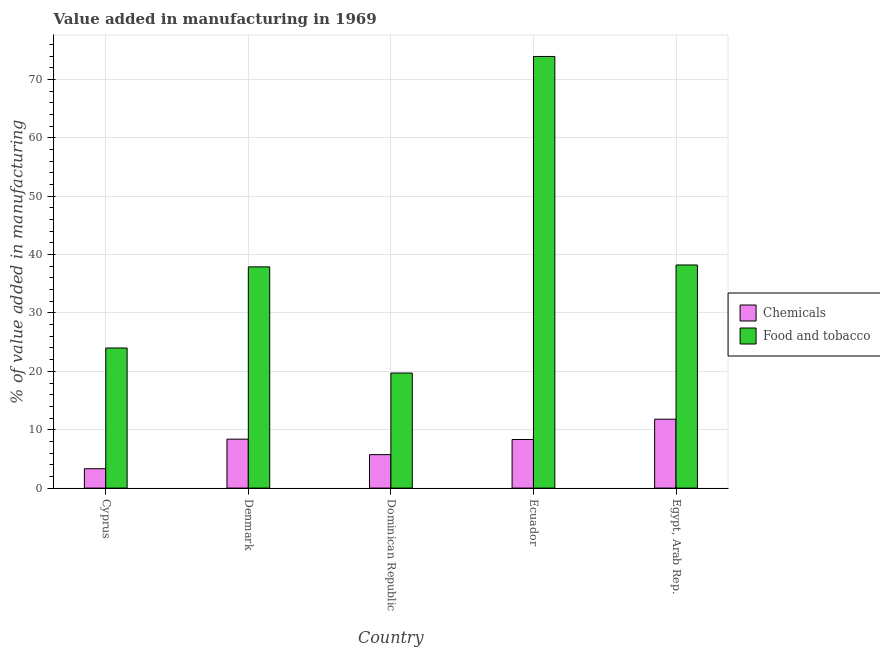How many different coloured bars are there?
Make the answer very short. 2. Are the number of bars on each tick of the X-axis equal?
Offer a terse response. Yes. How many bars are there on the 3rd tick from the left?
Give a very brief answer. 2. How many bars are there on the 3rd tick from the right?
Offer a very short reply. 2. What is the label of the 5th group of bars from the left?
Ensure brevity in your answer.  Egypt, Arab Rep. What is the value added by  manufacturing chemicals in Egypt, Arab Rep.?
Keep it short and to the point. 11.8. Across all countries, what is the maximum value added by  manufacturing chemicals?
Provide a short and direct response. 11.8. Across all countries, what is the minimum value added by manufacturing food and tobacco?
Your answer should be very brief. 19.71. In which country was the value added by manufacturing food and tobacco maximum?
Offer a very short reply. Ecuador. In which country was the value added by  manufacturing chemicals minimum?
Your answer should be compact. Cyprus. What is the total value added by manufacturing food and tobacco in the graph?
Give a very brief answer. 193.76. What is the difference between the value added by  manufacturing chemicals in Denmark and that in Ecuador?
Offer a terse response. 0.06. What is the difference between the value added by  manufacturing chemicals in Cyprus and the value added by manufacturing food and tobacco in Egypt, Arab Rep.?
Give a very brief answer. -34.9. What is the average value added by manufacturing food and tobacco per country?
Make the answer very short. 38.75. What is the difference between the value added by  manufacturing chemicals and value added by manufacturing food and tobacco in Dominican Republic?
Give a very brief answer. -13.98. What is the ratio of the value added by manufacturing food and tobacco in Cyprus to that in Dominican Republic?
Keep it short and to the point. 1.22. Is the value added by  manufacturing chemicals in Dominican Republic less than that in Ecuador?
Keep it short and to the point. Yes. Is the difference between the value added by  manufacturing chemicals in Cyprus and Egypt, Arab Rep. greater than the difference between the value added by manufacturing food and tobacco in Cyprus and Egypt, Arab Rep.?
Your answer should be very brief. Yes. What is the difference between the highest and the second highest value added by  manufacturing chemicals?
Offer a terse response. 3.42. What is the difference between the highest and the lowest value added by  manufacturing chemicals?
Provide a succinct answer. 8.48. In how many countries, is the value added by manufacturing food and tobacco greater than the average value added by manufacturing food and tobacco taken over all countries?
Your response must be concise. 1. Is the sum of the value added by  manufacturing chemicals in Denmark and Egypt, Arab Rep. greater than the maximum value added by manufacturing food and tobacco across all countries?
Your response must be concise. No. What does the 2nd bar from the left in Egypt, Arab Rep. represents?
Make the answer very short. Food and tobacco. What does the 2nd bar from the right in Cyprus represents?
Offer a terse response. Chemicals. Are all the bars in the graph horizontal?
Give a very brief answer. No. What is the difference between two consecutive major ticks on the Y-axis?
Give a very brief answer. 10. Are the values on the major ticks of Y-axis written in scientific E-notation?
Your response must be concise. No. Does the graph contain any zero values?
Offer a terse response. No. Where does the legend appear in the graph?
Your answer should be very brief. Center right. How many legend labels are there?
Make the answer very short. 2. How are the legend labels stacked?
Keep it short and to the point. Vertical. What is the title of the graph?
Give a very brief answer. Value added in manufacturing in 1969. Does "Public credit registry" appear as one of the legend labels in the graph?
Provide a succinct answer. No. What is the label or title of the X-axis?
Give a very brief answer. Country. What is the label or title of the Y-axis?
Your response must be concise. % of value added in manufacturing. What is the % of value added in manufacturing of Chemicals in Cyprus?
Provide a short and direct response. 3.32. What is the % of value added in manufacturing of Food and tobacco in Cyprus?
Your answer should be compact. 24. What is the % of value added in manufacturing in Chemicals in Denmark?
Your answer should be compact. 8.38. What is the % of value added in manufacturing of Food and tobacco in Denmark?
Keep it short and to the point. 37.9. What is the % of value added in manufacturing of Chemicals in Dominican Republic?
Ensure brevity in your answer.  5.73. What is the % of value added in manufacturing of Food and tobacco in Dominican Republic?
Keep it short and to the point. 19.71. What is the % of value added in manufacturing of Chemicals in Ecuador?
Your response must be concise. 8.33. What is the % of value added in manufacturing of Food and tobacco in Ecuador?
Your response must be concise. 73.94. What is the % of value added in manufacturing in Chemicals in Egypt, Arab Rep.?
Keep it short and to the point. 11.8. What is the % of value added in manufacturing of Food and tobacco in Egypt, Arab Rep.?
Ensure brevity in your answer.  38.22. Across all countries, what is the maximum % of value added in manufacturing of Chemicals?
Your response must be concise. 11.8. Across all countries, what is the maximum % of value added in manufacturing of Food and tobacco?
Ensure brevity in your answer.  73.94. Across all countries, what is the minimum % of value added in manufacturing in Chemicals?
Your answer should be compact. 3.32. Across all countries, what is the minimum % of value added in manufacturing in Food and tobacco?
Ensure brevity in your answer.  19.71. What is the total % of value added in manufacturing in Chemicals in the graph?
Ensure brevity in your answer.  37.56. What is the total % of value added in manufacturing of Food and tobacco in the graph?
Provide a short and direct response. 193.76. What is the difference between the % of value added in manufacturing in Chemicals in Cyprus and that in Denmark?
Keep it short and to the point. -5.06. What is the difference between the % of value added in manufacturing of Food and tobacco in Cyprus and that in Denmark?
Your answer should be compact. -13.9. What is the difference between the % of value added in manufacturing of Chemicals in Cyprus and that in Dominican Republic?
Offer a very short reply. -2.41. What is the difference between the % of value added in manufacturing of Food and tobacco in Cyprus and that in Dominican Republic?
Keep it short and to the point. 4.29. What is the difference between the % of value added in manufacturing in Chemicals in Cyprus and that in Ecuador?
Provide a short and direct response. -5.01. What is the difference between the % of value added in manufacturing in Food and tobacco in Cyprus and that in Ecuador?
Provide a succinct answer. -49.94. What is the difference between the % of value added in manufacturing in Chemicals in Cyprus and that in Egypt, Arab Rep.?
Provide a short and direct response. -8.48. What is the difference between the % of value added in manufacturing of Food and tobacco in Cyprus and that in Egypt, Arab Rep.?
Offer a very short reply. -14.22. What is the difference between the % of value added in manufacturing in Chemicals in Denmark and that in Dominican Republic?
Ensure brevity in your answer.  2.65. What is the difference between the % of value added in manufacturing in Food and tobacco in Denmark and that in Dominican Republic?
Offer a very short reply. 18.19. What is the difference between the % of value added in manufacturing in Chemicals in Denmark and that in Ecuador?
Offer a very short reply. 0.06. What is the difference between the % of value added in manufacturing of Food and tobacco in Denmark and that in Ecuador?
Make the answer very short. -36.04. What is the difference between the % of value added in manufacturing of Chemicals in Denmark and that in Egypt, Arab Rep.?
Provide a succinct answer. -3.42. What is the difference between the % of value added in manufacturing of Food and tobacco in Denmark and that in Egypt, Arab Rep.?
Offer a very short reply. -0.33. What is the difference between the % of value added in manufacturing in Chemicals in Dominican Republic and that in Ecuador?
Provide a succinct answer. -2.59. What is the difference between the % of value added in manufacturing in Food and tobacco in Dominican Republic and that in Ecuador?
Your response must be concise. -54.23. What is the difference between the % of value added in manufacturing of Chemicals in Dominican Republic and that in Egypt, Arab Rep.?
Your answer should be very brief. -6.07. What is the difference between the % of value added in manufacturing of Food and tobacco in Dominican Republic and that in Egypt, Arab Rep.?
Your answer should be compact. -18.51. What is the difference between the % of value added in manufacturing in Chemicals in Ecuador and that in Egypt, Arab Rep.?
Make the answer very short. -3.48. What is the difference between the % of value added in manufacturing in Food and tobacco in Ecuador and that in Egypt, Arab Rep.?
Ensure brevity in your answer.  35.72. What is the difference between the % of value added in manufacturing of Chemicals in Cyprus and the % of value added in manufacturing of Food and tobacco in Denmark?
Your answer should be very brief. -34.58. What is the difference between the % of value added in manufacturing of Chemicals in Cyprus and the % of value added in manufacturing of Food and tobacco in Dominican Republic?
Offer a terse response. -16.39. What is the difference between the % of value added in manufacturing in Chemicals in Cyprus and the % of value added in manufacturing in Food and tobacco in Ecuador?
Offer a terse response. -70.62. What is the difference between the % of value added in manufacturing of Chemicals in Cyprus and the % of value added in manufacturing of Food and tobacco in Egypt, Arab Rep.?
Make the answer very short. -34.9. What is the difference between the % of value added in manufacturing in Chemicals in Denmark and the % of value added in manufacturing in Food and tobacco in Dominican Republic?
Offer a terse response. -11.33. What is the difference between the % of value added in manufacturing of Chemicals in Denmark and the % of value added in manufacturing of Food and tobacco in Ecuador?
Give a very brief answer. -65.56. What is the difference between the % of value added in manufacturing in Chemicals in Denmark and the % of value added in manufacturing in Food and tobacco in Egypt, Arab Rep.?
Provide a succinct answer. -29.84. What is the difference between the % of value added in manufacturing in Chemicals in Dominican Republic and the % of value added in manufacturing in Food and tobacco in Ecuador?
Your response must be concise. -68.21. What is the difference between the % of value added in manufacturing in Chemicals in Dominican Republic and the % of value added in manufacturing in Food and tobacco in Egypt, Arab Rep.?
Your answer should be compact. -32.49. What is the difference between the % of value added in manufacturing of Chemicals in Ecuador and the % of value added in manufacturing of Food and tobacco in Egypt, Arab Rep.?
Your answer should be very brief. -29.89. What is the average % of value added in manufacturing in Chemicals per country?
Offer a very short reply. 7.51. What is the average % of value added in manufacturing in Food and tobacco per country?
Offer a very short reply. 38.75. What is the difference between the % of value added in manufacturing of Chemicals and % of value added in manufacturing of Food and tobacco in Cyprus?
Keep it short and to the point. -20.68. What is the difference between the % of value added in manufacturing in Chemicals and % of value added in manufacturing in Food and tobacco in Denmark?
Your answer should be very brief. -29.51. What is the difference between the % of value added in manufacturing of Chemicals and % of value added in manufacturing of Food and tobacco in Dominican Republic?
Make the answer very short. -13.98. What is the difference between the % of value added in manufacturing of Chemicals and % of value added in manufacturing of Food and tobacco in Ecuador?
Make the answer very short. -65.61. What is the difference between the % of value added in manufacturing in Chemicals and % of value added in manufacturing in Food and tobacco in Egypt, Arab Rep.?
Provide a short and direct response. -26.42. What is the ratio of the % of value added in manufacturing in Chemicals in Cyprus to that in Denmark?
Provide a short and direct response. 0.4. What is the ratio of the % of value added in manufacturing in Food and tobacco in Cyprus to that in Denmark?
Make the answer very short. 0.63. What is the ratio of the % of value added in manufacturing in Chemicals in Cyprus to that in Dominican Republic?
Provide a succinct answer. 0.58. What is the ratio of the % of value added in manufacturing in Food and tobacco in Cyprus to that in Dominican Republic?
Make the answer very short. 1.22. What is the ratio of the % of value added in manufacturing of Chemicals in Cyprus to that in Ecuador?
Provide a short and direct response. 0.4. What is the ratio of the % of value added in manufacturing in Food and tobacco in Cyprus to that in Ecuador?
Ensure brevity in your answer.  0.32. What is the ratio of the % of value added in manufacturing in Chemicals in Cyprus to that in Egypt, Arab Rep.?
Your answer should be very brief. 0.28. What is the ratio of the % of value added in manufacturing of Food and tobacco in Cyprus to that in Egypt, Arab Rep.?
Your answer should be compact. 0.63. What is the ratio of the % of value added in manufacturing in Chemicals in Denmark to that in Dominican Republic?
Provide a short and direct response. 1.46. What is the ratio of the % of value added in manufacturing in Food and tobacco in Denmark to that in Dominican Republic?
Make the answer very short. 1.92. What is the ratio of the % of value added in manufacturing of Chemicals in Denmark to that in Ecuador?
Your answer should be very brief. 1.01. What is the ratio of the % of value added in manufacturing of Food and tobacco in Denmark to that in Ecuador?
Your response must be concise. 0.51. What is the ratio of the % of value added in manufacturing in Chemicals in Denmark to that in Egypt, Arab Rep.?
Provide a short and direct response. 0.71. What is the ratio of the % of value added in manufacturing in Chemicals in Dominican Republic to that in Ecuador?
Your response must be concise. 0.69. What is the ratio of the % of value added in manufacturing of Food and tobacco in Dominican Republic to that in Ecuador?
Provide a short and direct response. 0.27. What is the ratio of the % of value added in manufacturing in Chemicals in Dominican Republic to that in Egypt, Arab Rep.?
Your answer should be very brief. 0.49. What is the ratio of the % of value added in manufacturing of Food and tobacco in Dominican Republic to that in Egypt, Arab Rep.?
Give a very brief answer. 0.52. What is the ratio of the % of value added in manufacturing of Chemicals in Ecuador to that in Egypt, Arab Rep.?
Make the answer very short. 0.71. What is the ratio of the % of value added in manufacturing of Food and tobacco in Ecuador to that in Egypt, Arab Rep.?
Your response must be concise. 1.93. What is the difference between the highest and the second highest % of value added in manufacturing in Chemicals?
Your response must be concise. 3.42. What is the difference between the highest and the second highest % of value added in manufacturing of Food and tobacco?
Offer a very short reply. 35.72. What is the difference between the highest and the lowest % of value added in manufacturing of Chemicals?
Keep it short and to the point. 8.48. What is the difference between the highest and the lowest % of value added in manufacturing in Food and tobacco?
Offer a terse response. 54.23. 